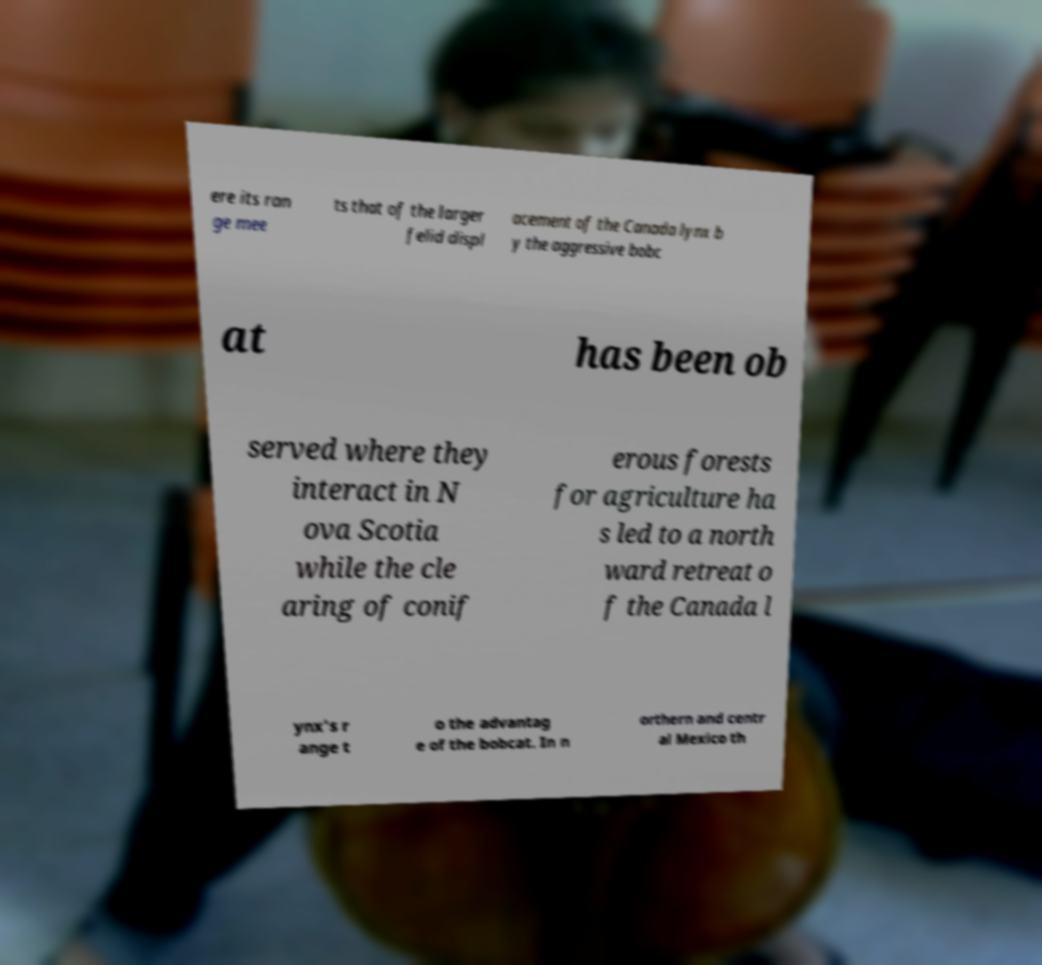Can you accurately transcribe the text from the provided image for me? ere its ran ge mee ts that of the larger felid displ acement of the Canada lynx b y the aggressive bobc at has been ob served where they interact in N ova Scotia while the cle aring of conif erous forests for agriculture ha s led to a north ward retreat o f the Canada l ynx's r ange t o the advantag e of the bobcat. In n orthern and centr al Mexico th 